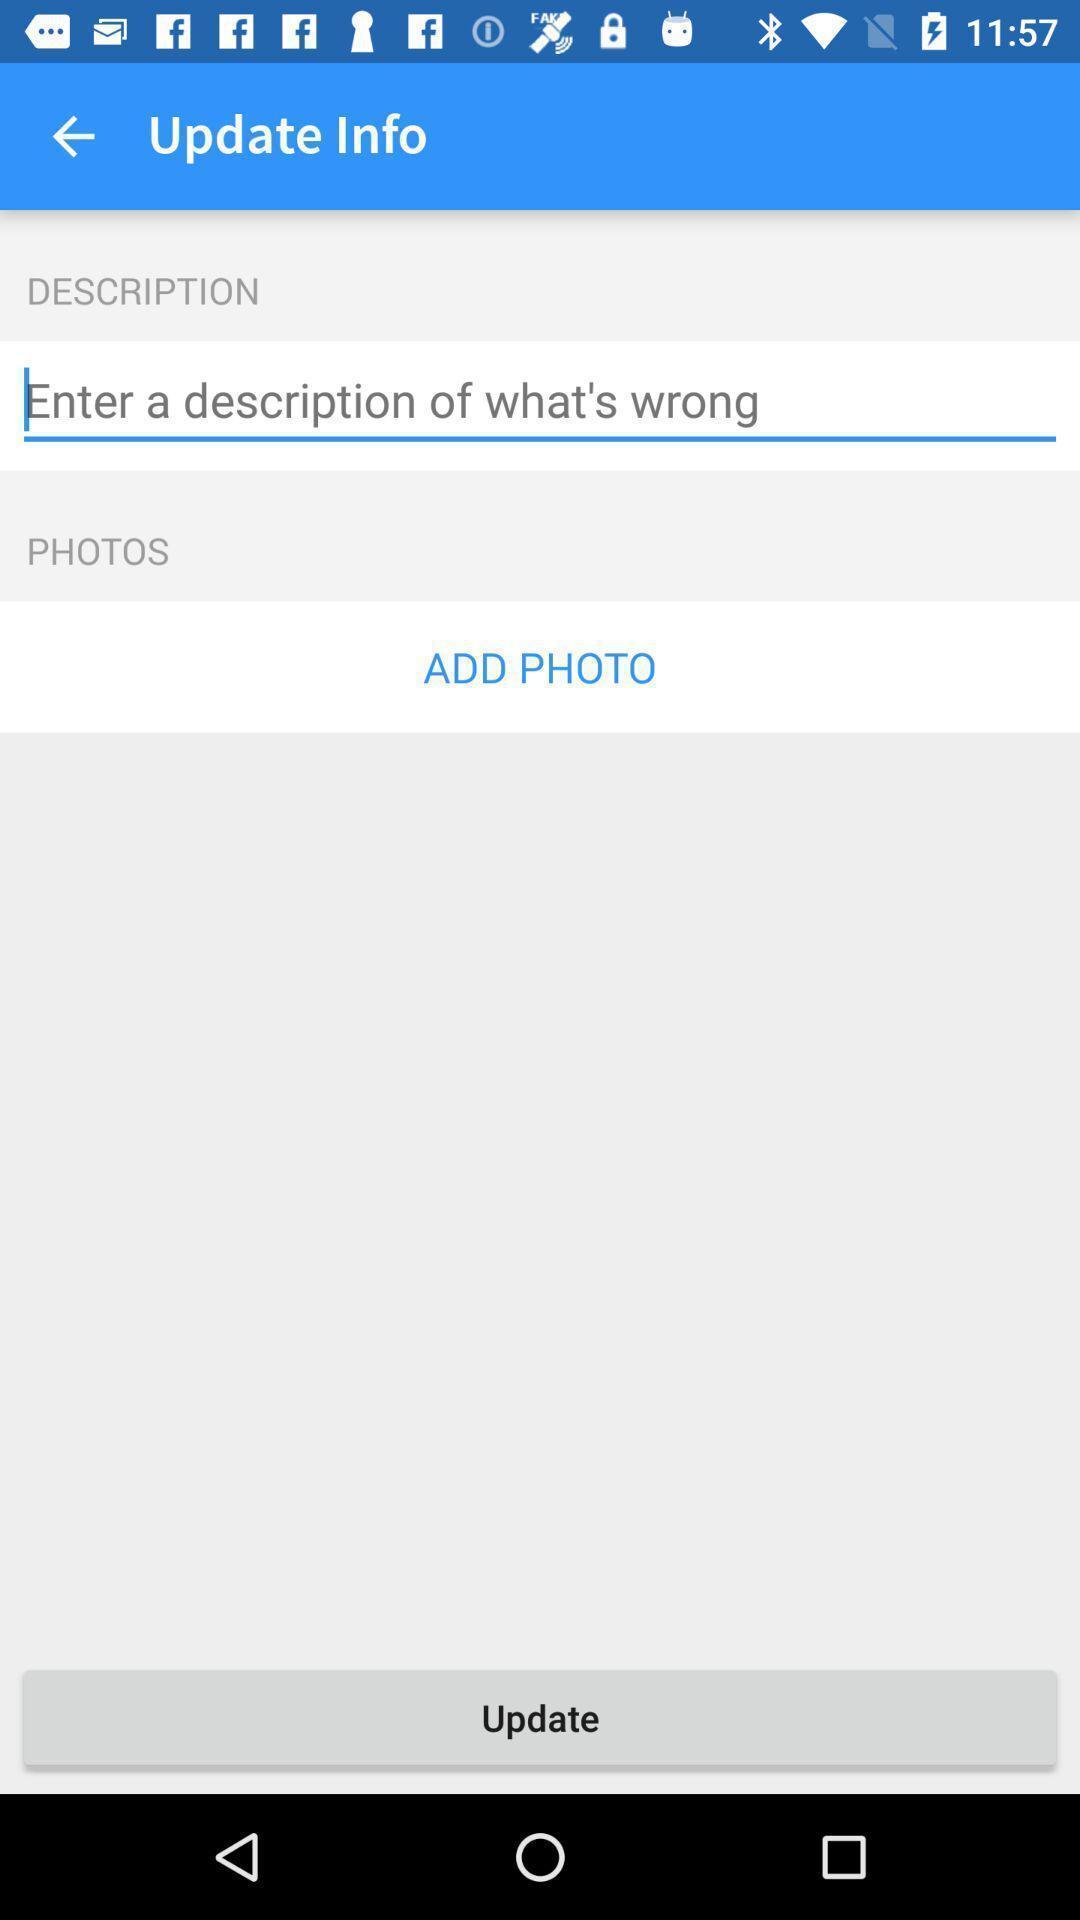Give me a narrative description of this picture. Screen displaying update information page. 